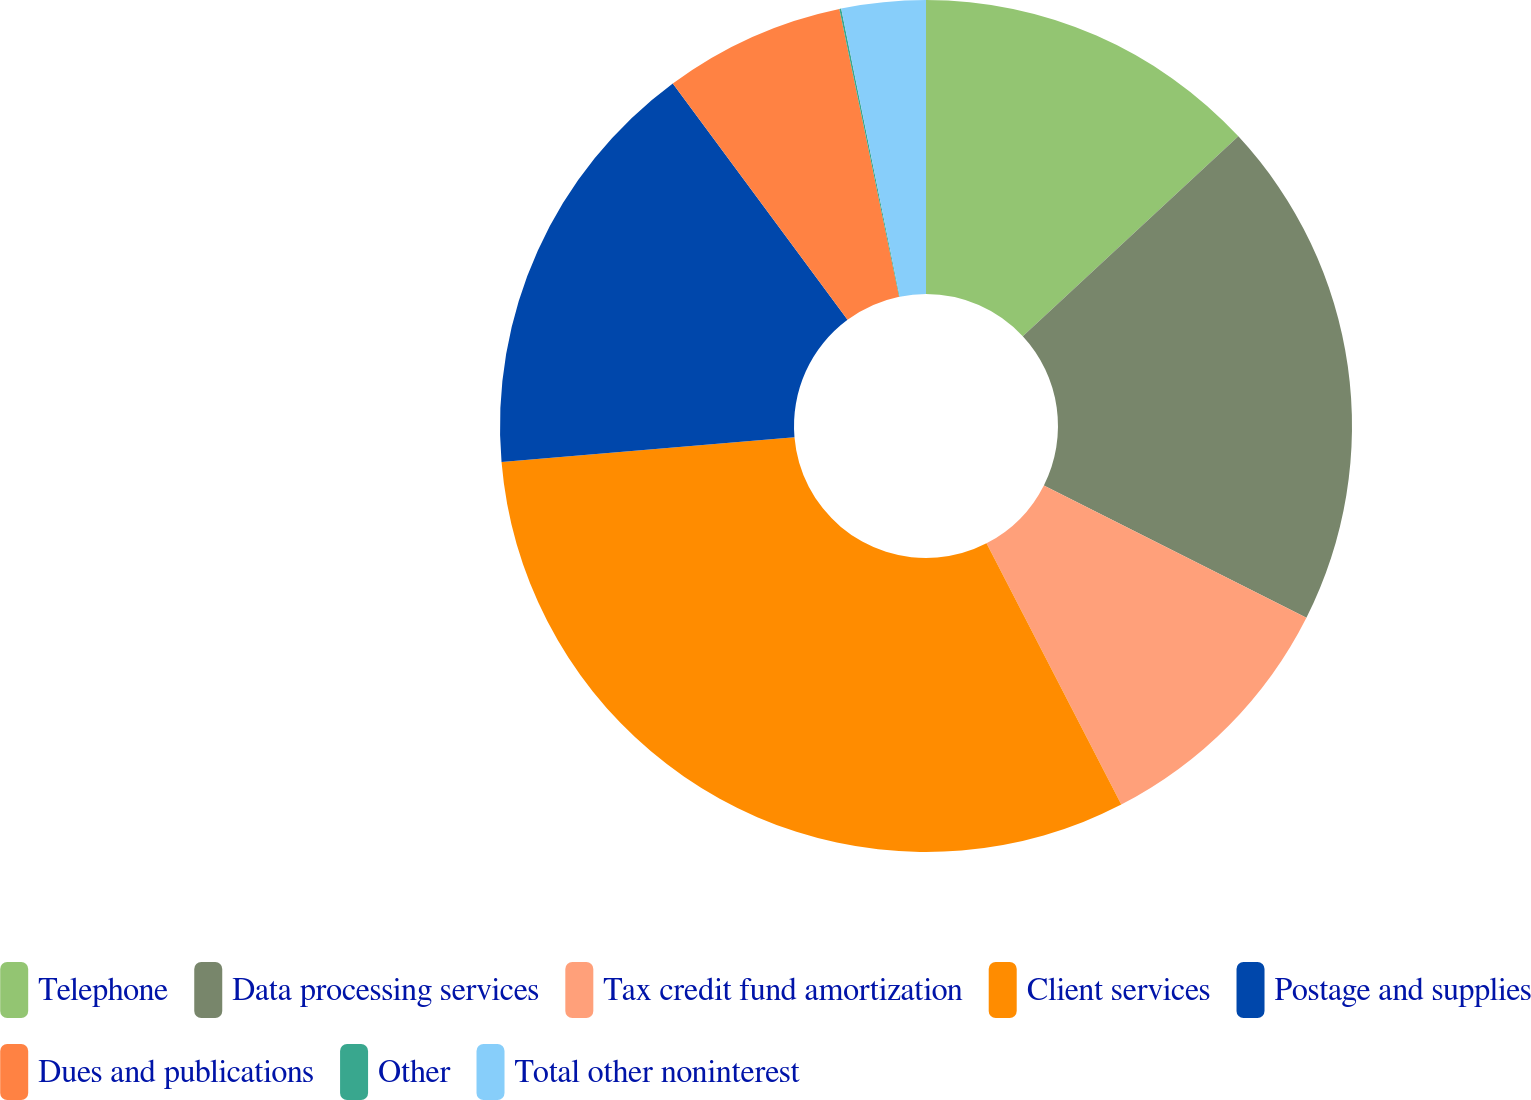Convert chart to OTSL. <chart><loc_0><loc_0><loc_500><loc_500><pie_chart><fcel>Telephone<fcel>Data processing services<fcel>Tax credit fund amortization<fcel>Client services<fcel>Postage and supplies<fcel>Dues and publications<fcel>Other<fcel>Total other noninterest<nl><fcel>13.1%<fcel>19.33%<fcel>9.99%<fcel>31.23%<fcel>16.22%<fcel>6.87%<fcel>0.07%<fcel>3.19%<nl></chart> 